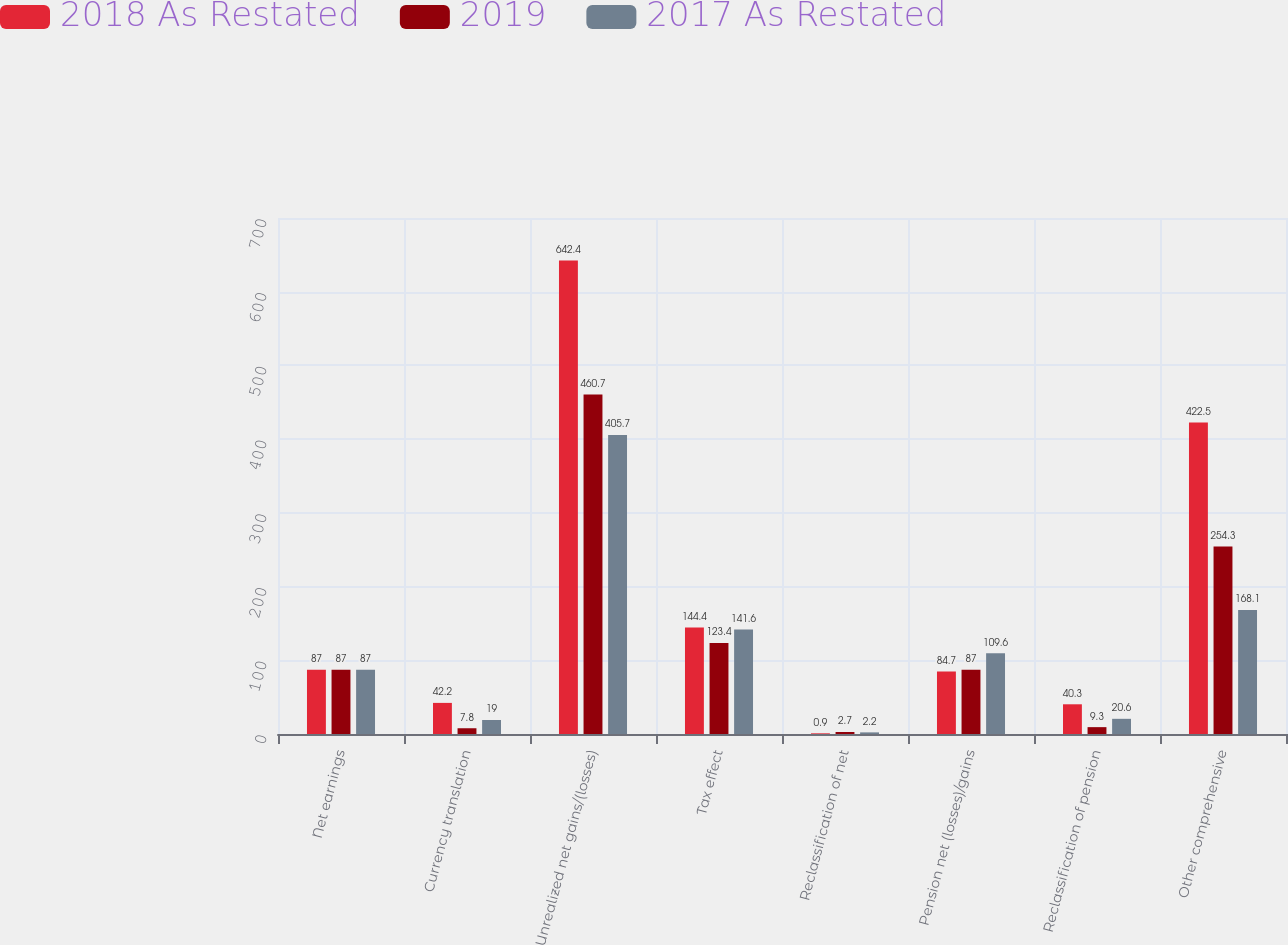Convert chart to OTSL. <chart><loc_0><loc_0><loc_500><loc_500><stacked_bar_chart><ecel><fcel>Net earnings<fcel>Currency translation<fcel>Unrealized net gains/(losses)<fcel>Tax effect<fcel>Reclassification of net<fcel>Pension net (losses)/gains<fcel>Reclassification of pension<fcel>Other comprehensive<nl><fcel>2018 As Restated<fcel>87<fcel>42.2<fcel>642.4<fcel>144.4<fcel>0.9<fcel>84.7<fcel>40.3<fcel>422.5<nl><fcel>2019<fcel>87<fcel>7.8<fcel>460.7<fcel>123.4<fcel>2.7<fcel>87<fcel>9.3<fcel>254.3<nl><fcel>2017 As Restated<fcel>87<fcel>19<fcel>405.7<fcel>141.6<fcel>2.2<fcel>109.6<fcel>20.6<fcel>168.1<nl></chart> 